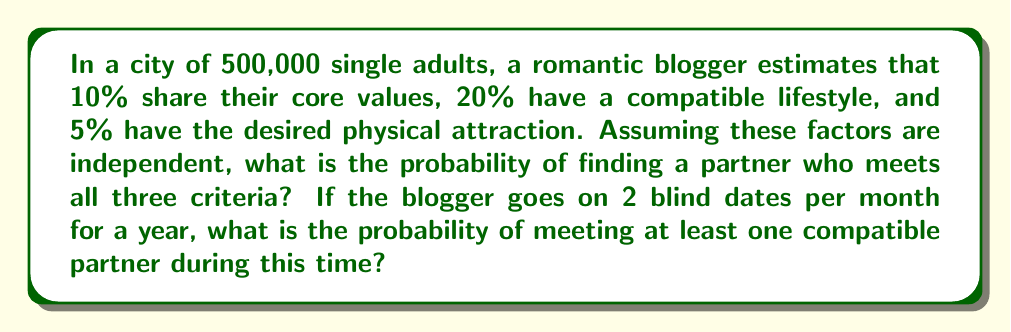Can you answer this question? Let's approach this step-by-step:

1) First, we need to calculate the probability of finding a single person who meets all three criteria:

   $P(\text{compatible}) = P(\text{values}) \times P(\text{lifestyle}) \times P(\text{attraction})$
   $= 0.10 \times 0.20 \times 0.05 = 0.001 = 0.1\%$

2) This means that out of the 500,000 single adults, the number of compatible partners is:
   
   $500,000 \times 0.001 = 500$

3) Now, for each date, the probability of meeting a compatible partner is:

   $P(\text{compatible date}) = \frac{500}{500,000} = 0.001 = 0.1\%$

4) The probability of not meeting a compatible partner on a single date is:

   $P(\text{not compatible}) = 1 - 0.001 = 0.999 = 99.9\%$

5) Over a year, the blogger goes on $2 \times 12 = 24$ dates. The probability of not meeting any compatible partner in 24 dates is:

   $P(\text{no compatible in 24 dates}) = (0.999)^{24} \approx 0.9788$

6) Therefore, the probability of meeting at least one compatible partner is:

   $P(\text{at least one compatible}) = 1 - P(\text{no compatible in 24 dates})$
   $= 1 - 0.9788 \approx 0.0212 = 2.12\%$
Answer: $2.12\%$ 